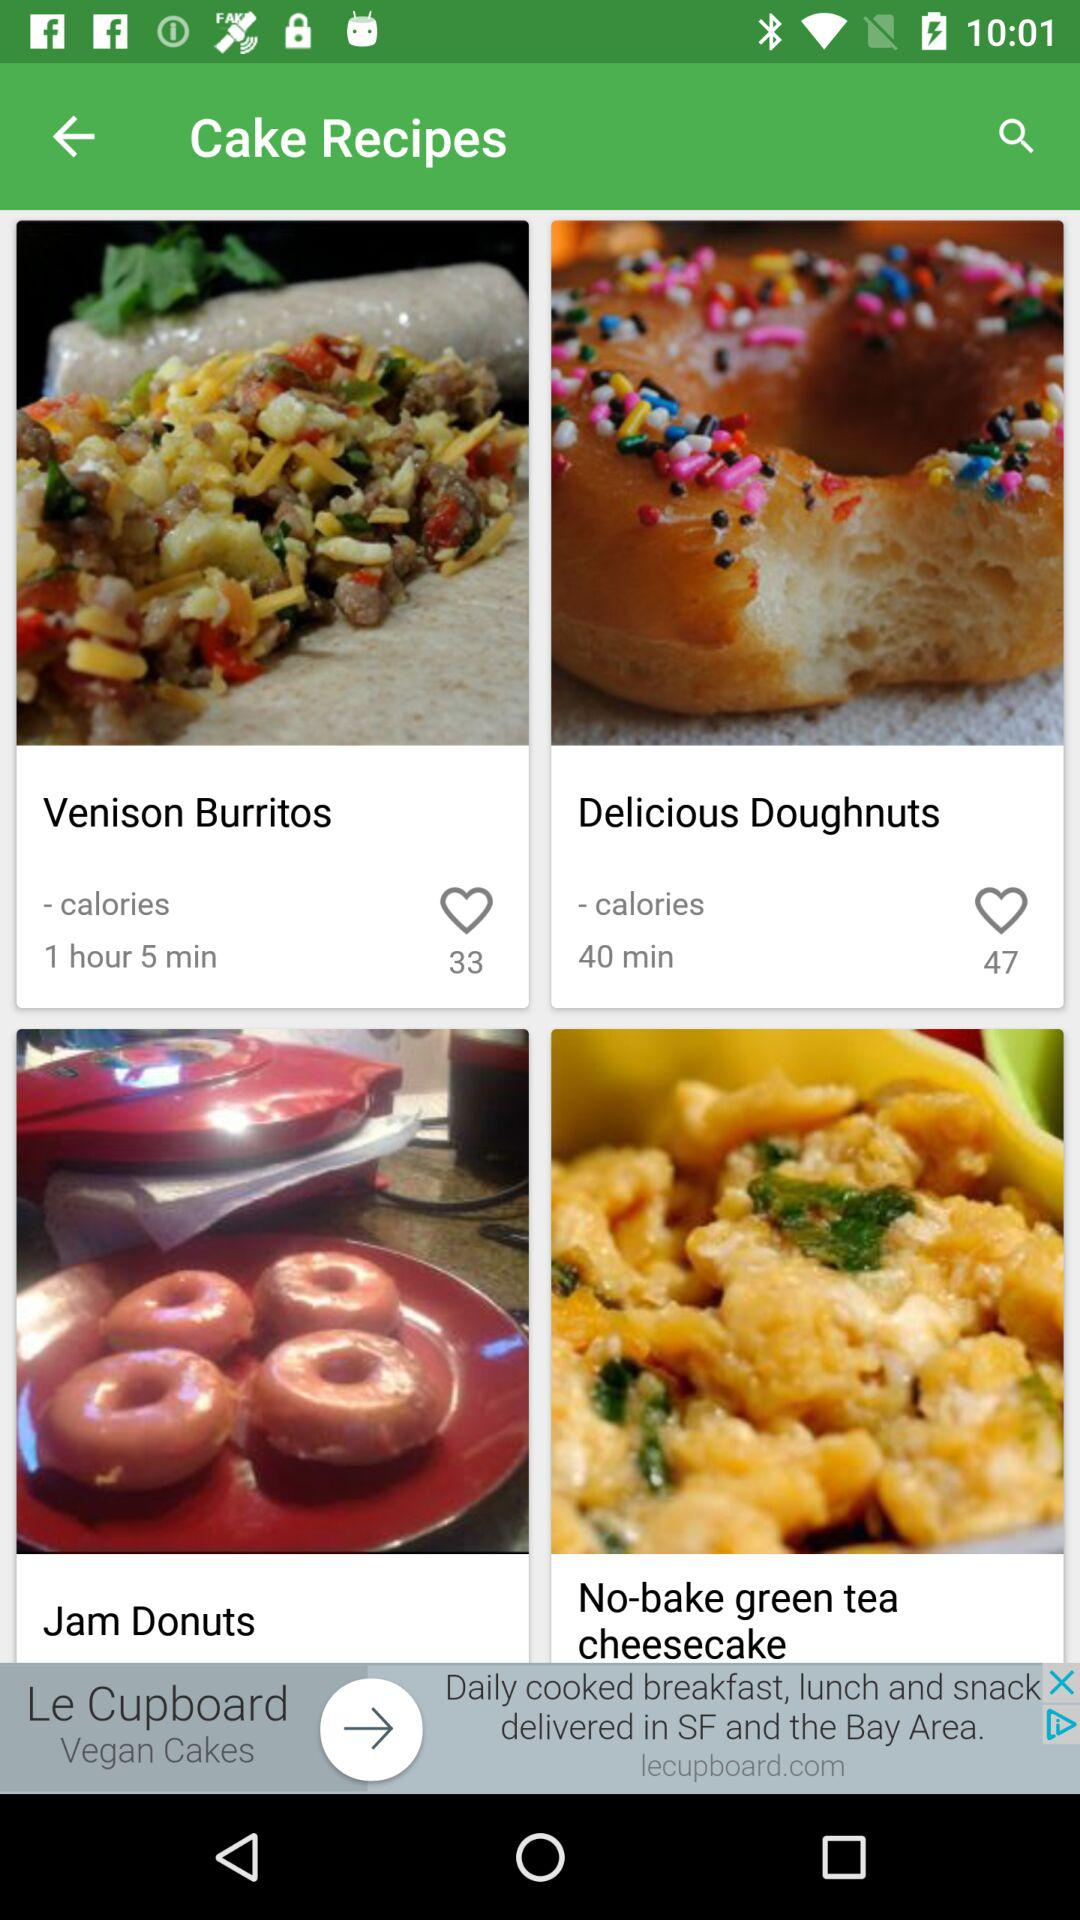How many likes did "Venison Burritos" recipe receive? The recipe received 33 likes. 